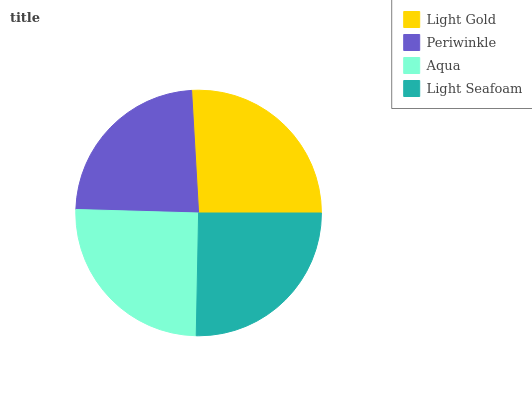Is Periwinkle the minimum?
Answer yes or no. Yes. Is Light Gold the maximum?
Answer yes or no. Yes. Is Aqua the minimum?
Answer yes or no. No. Is Aqua the maximum?
Answer yes or no. No. Is Aqua greater than Periwinkle?
Answer yes or no. Yes. Is Periwinkle less than Aqua?
Answer yes or no. Yes. Is Periwinkle greater than Aqua?
Answer yes or no. No. Is Aqua less than Periwinkle?
Answer yes or no. No. Is Light Seafoam the high median?
Answer yes or no. Yes. Is Aqua the low median?
Answer yes or no. Yes. Is Aqua the high median?
Answer yes or no. No. Is Light Gold the low median?
Answer yes or no. No. 